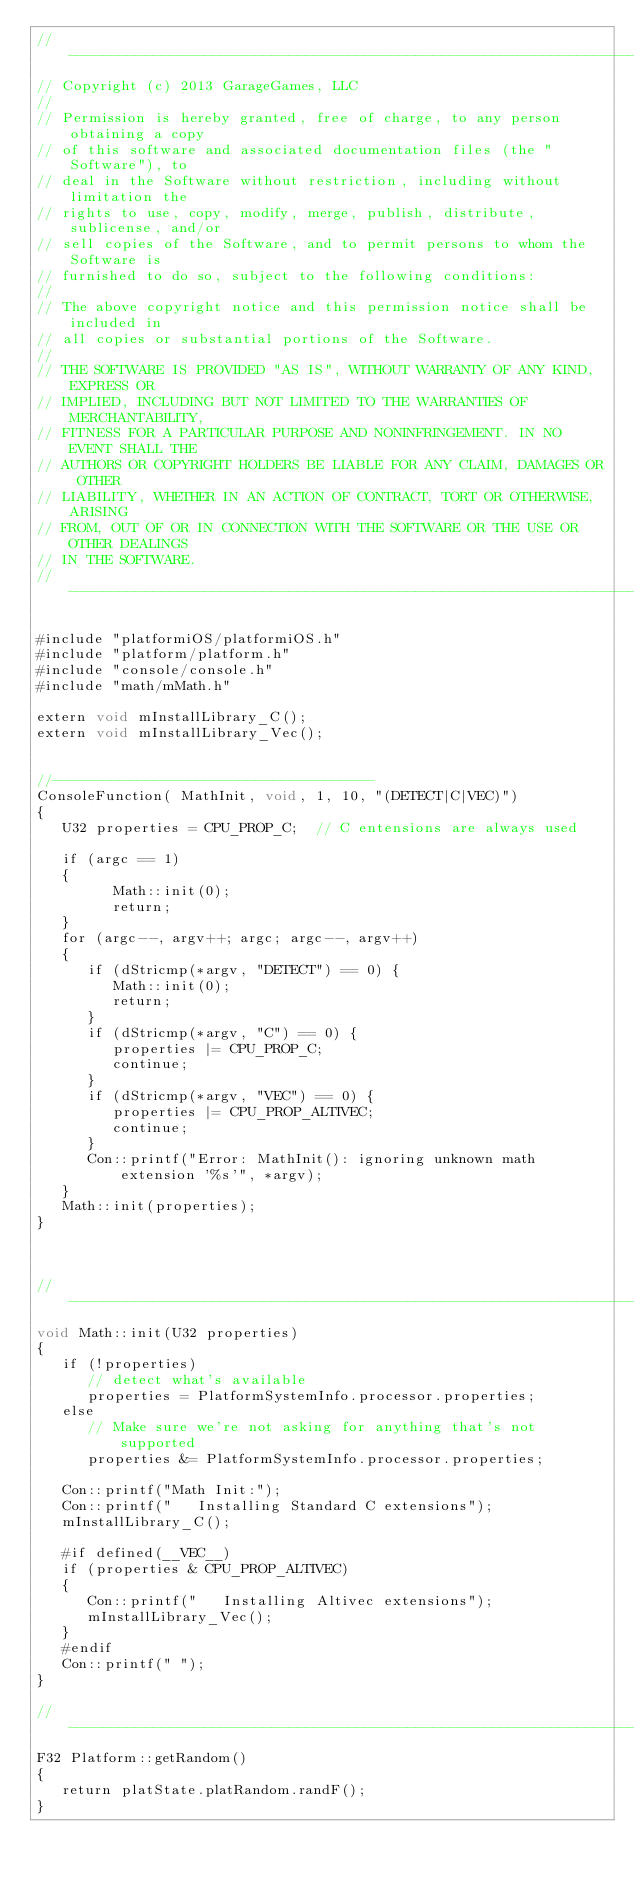<code> <loc_0><loc_0><loc_500><loc_500><_ObjectiveC_>//-----------------------------------------------------------------------------
// Copyright (c) 2013 GarageGames, LLC
//
// Permission is hereby granted, free of charge, to any person obtaining a copy
// of this software and associated documentation files (the "Software"), to
// deal in the Software without restriction, including without limitation the
// rights to use, copy, modify, merge, publish, distribute, sublicense, and/or
// sell copies of the Software, and to permit persons to whom the Software is
// furnished to do so, subject to the following conditions:
//
// The above copyright notice and this permission notice shall be included in
// all copies or substantial portions of the Software.
//
// THE SOFTWARE IS PROVIDED "AS IS", WITHOUT WARRANTY OF ANY KIND, EXPRESS OR
// IMPLIED, INCLUDING BUT NOT LIMITED TO THE WARRANTIES OF MERCHANTABILITY,
// FITNESS FOR A PARTICULAR PURPOSE AND NONINFRINGEMENT. IN NO EVENT SHALL THE
// AUTHORS OR COPYRIGHT HOLDERS BE LIABLE FOR ANY CLAIM, DAMAGES OR OTHER
// LIABILITY, WHETHER IN AN ACTION OF CONTRACT, TORT OR OTHERWISE, ARISING
// FROM, OUT OF OR IN CONNECTION WITH THE SOFTWARE OR THE USE OR OTHER DEALINGS
// IN THE SOFTWARE.
//-----------------------------------------------------------------------------

#include "platformiOS/platformiOS.h"
#include "platform/platform.h"
#include "console/console.h"
#include "math/mMath.h"

extern void mInstallLibrary_C();
extern void mInstallLibrary_Vec();


//--------------------------------------
ConsoleFunction( MathInit, void, 1, 10, "(DETECT|C|VEC)")
{
   U32 properties = CPU_PROP_C;  // C entensions are always used
   
   if (argc == 1)
   {
         Math::init(0);
         return;
   }
   for (argc--, argv++; argc; argc--, argv++)
   {
      if (dStricmp(*argv, "DETECT") == 0) { 
         Math::init(0);
         return;
      }
      if (dStricmp(*argv, "C") == 0) { 
         properties |= CPU_PROP_C; 
         continue; 
      }
      if (dStricmp(*argv, "VEC") == 0) { 
         properties |= CPU_PROP_ALTIVEC; 
         continue; 
      }
      Con::printf("Error: MathInit(): ignoring unknown math extension '%s'", *argv);
   }
   Math::init(properties);
}



//------------------------------------------------------------------------------
void Math::init(U32 properties)
{
   if (!properties)
      // detect what's available
      properties = PlatformSystemInfo.processor.properties;  
   else
      // Make sure we're not asking for anything that's not supported
      properties &= PlatformSystemInfo.processor.properties;  

   Con::printf("Math Init:");
   Con::printf("   Installing Standard C extensions");
   mInstallLibrary_C();
   
   #if defined(__VEC__)
   if (properties & CPU_PROP_ALTIVEC)
   {
      Con::printf("   Installing Altivec extensions");
      mInstallLibrary_Vec();
   }
   #endif
   Con::printf(" ");
}   

//------------------------------------------------------------------------------
F32 Platform::getRandom()
{
   return platState.platRandom.randF();
}

</code> 